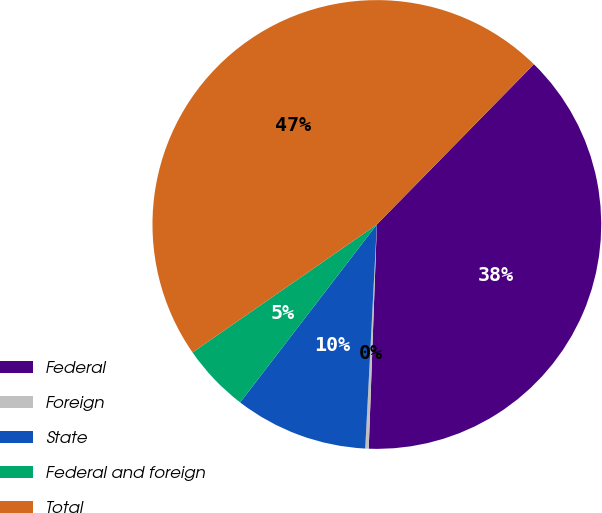Convert chart to OTSL. <chart><loc_0><loc_0><loc_500><loc_500><pie_chart><fcel>Federal<fcel>Foreign<fcel>State<fcel>Federal and foreign<fcel>Total<nl><fcel>38.24%<fcel>0.25%<fcel>9.6%<fcel>4.92%<fcel>47.0%<nl></chart> 